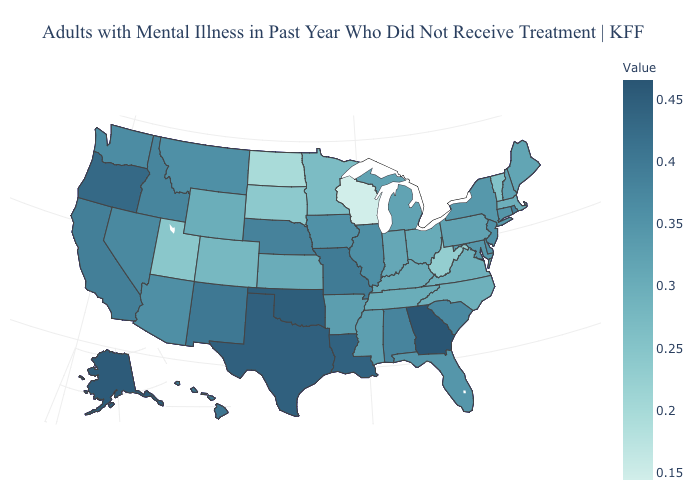Does Rhode Island have the highest value in the Northeast?
Short answer required. Yes. Does Pennsylvania have the lowest value in the Northeast?
Short answer required. No. Among the states that border Kentucky , which have the highest value?
Be succinct. Missouri. Which states have the highest value in the USA?
Quick response, please. Georgia. Among the states that border Connecticut , which have the highest value?
Answer briefly. Rhode Island. Among the states that border West Virginia , which have the lowest value?
Concise answer only. Virginia. Among the states that border Arkansas , does Oklahoma have the highest value?
Quick response, please. Yes. Does the map have missing data?
Be succinct. No. 